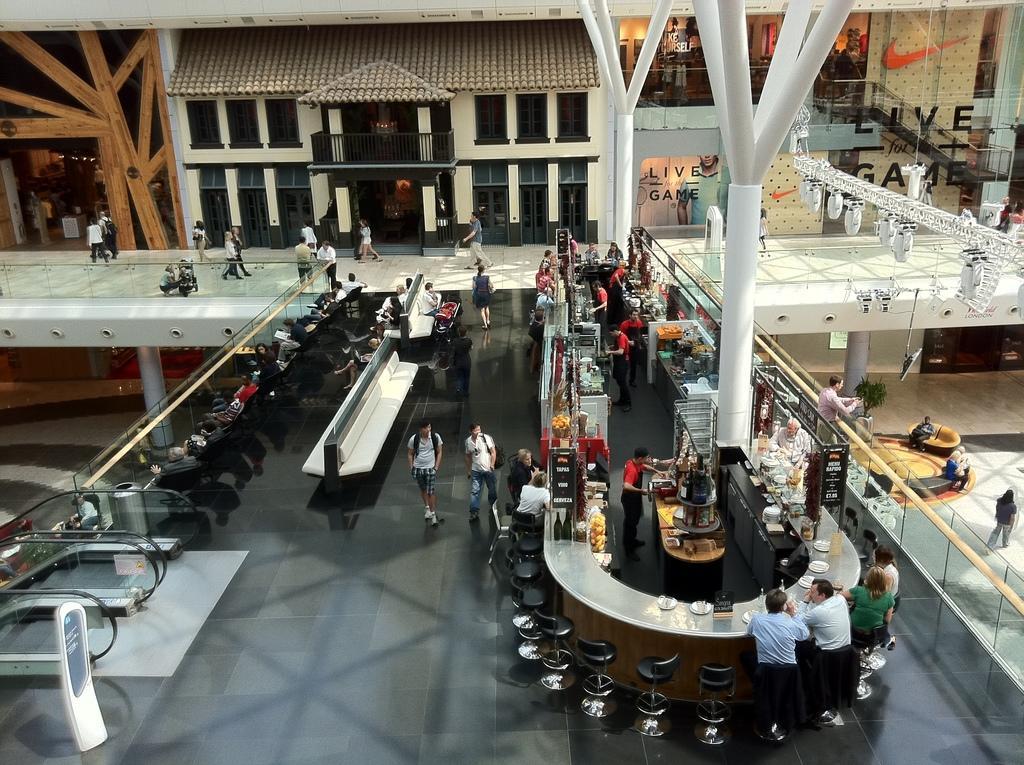Could you give a brief overview of what you see in this image? In this image we can see buildings, people, chairs, escalators, lights, pillars, railing and bench. 